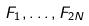<formula> <loc_0><loc_0><loc_500><loc_500>F _ { 1 } , \dots , F _ { 2 N }</formula> 